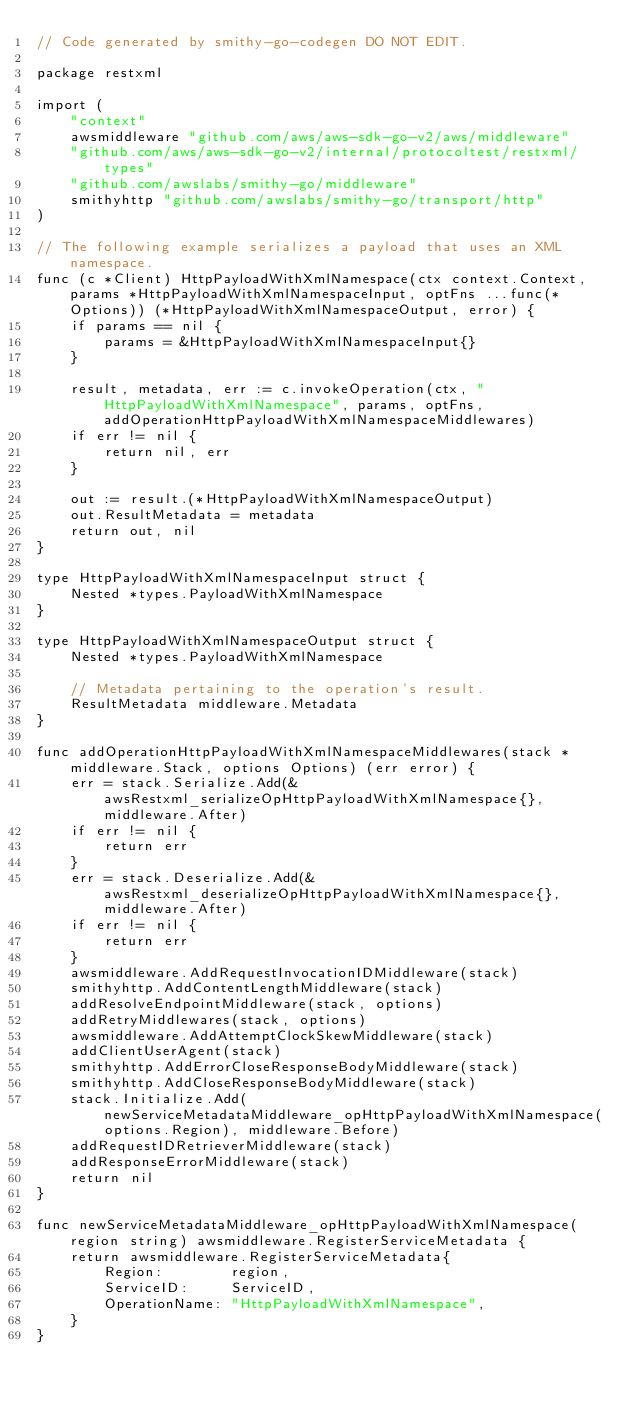Convert code to text. <code><loc_0><loc_0><loc_500><loc_500><_Go_>// Code generated by smithy-go-codegen DO NOT EDIT.

package restxml

import (
	"context"
	awsmiddleware "github.com/aws/aws-sdk-go-v2/aws/middleware"
	"github.com/aws/aws-sdk-go-v2/internal/protocoltest/restxml/types"
	"github.com/awslabs/smithy-go/middleware"
	smithyhttp "github.com/awslabs/smithy-go/transport/http"
)

// The following example serializes a payload that uses an XML namespace.
func (c *Client) HttpPayloadWithXmlNamespace(ctx context.Context, params *HttpPayloadWithXmlNamespaceInput, optFns ...func(*Options)) (*HttpPayloadWithXmlNamespaceOutput, error) {
	if params == nil {
		params = &HttpPayloadWithXmlNamespaceInput{}
	}

	result, metadata, err := c.invokeOperation(ctx, "HttpPayloadWithXmlNamespace", params, optFns, addOperationHttpPayloadWithXmlNamespaceMiddlewares)
	if err != nil {
		return nil, err
	}

	out := result.(*HttpPayloadWithXmlNamespaceOutput)
	out.ResultMetadata = metadata
	return out, nil
}

type HttpPayloadWithXmlNamespaceInput struct {
	Nested *types.PayloadWithXmlNamespace
}

type HttpPayloadWithXmlNamespaceOutput struct {
	Nested *types.PayloadWithXmlNamespace

	// Metadata pertaining to the operation's result.
	ResultMetadata middleware.Metadata
}

func addOperationHttpPayloadWithXmlNamespaceMiddlewares(stack *middleware.Stack, options Options) (err error) {
	err = stack.Serialize.Add(&awsRestxml_serializeOpHttpPayloadWithXmlNamespace{}, middleware.After)
	if err != nil {
		return err
	}
	err = stack.Deserialize.Add(&awsRestxml_deserializeOpHttpPayloadWithXmlNamespace{}, middleware.After)
	if err != nil {
		return err
	}
	awsmiddleware.AddRequestInvocationIDMiddleware(stack)
	smithyhttp.AddContentLengthMiddleware(stack)
	addResolveEndpointMiddleware(stack, options)
	addRetryMiddlewares(stack, options)
	awsmiddleware.AddAttemptClockSkewMiddleware(stack)
	addClientUserAgent(stack)
	smithyhttp.AddErrorCloseResponseBodyMiddleware(stack)
	smithyhttp.AddCloseResponseBodyMiddleware(stack)
	stack.Initialize.Add(newServiceMetadataMiddleware_opHttpPayloadWithXmlNamespace(options.Region), middleware.Before)
	addRequestIDRetrieverMiddleware(stack)
	addResponseErrorMiddleware(stack)
	return nil
}

func newServiceMetadataMiddleware_opHttpPayloadWithXmlNamespace(region string) awsmiddleware.RegisterServiceMetadata {
	return awsmiddleware.RegisterServiceMetadata{
		Region:        region,
		ServiceID:     ServiceID,
		OperationName: "HttpPayloadWithXmlNamespace",
	}
}
</code> 